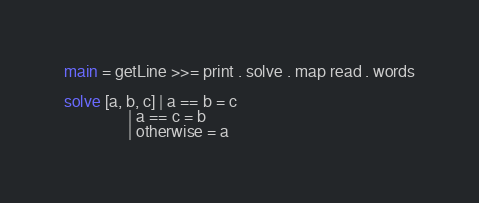<code> <loc_0><loc_0><loc_500><loc_500><_Haskell_>main = getLine >>= print . solve . map read . words

solve [a, b, c] | a == b = c
                | a == c = b
                | otherwise = a
</code> 